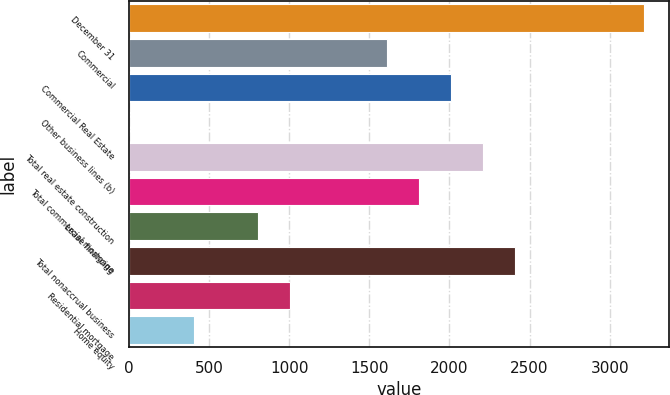Convert chart to OTSL. <chart><loc_0><loc_0><loc_500><loc_500><bar_chart><fcel>December 31<fcel>Commercial<fcel>Commercial Real Estate<fcel>Other business lines (b)<fcel>Total real estate construction<fcel>Total commercial mortgage<fcel>Lease financing<fcel>Total nonaccrual business<fcel>Residential mortgage<fcel>Home equity<nl><fcel>3212<fcel>1608<fcel>2009<fcel>4<fcel>2209.5<fcel>1808.5<fcel>806<fcel>2410<fcel>1006.5<fcel>405<nl></chart> 